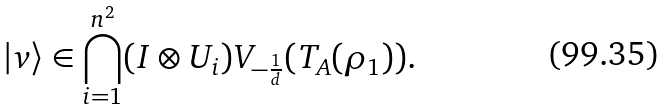Convert formula to latex. <formula><loc_0><loc_0><loc_500><loc_500>| v \rangle \in \bigcap _ { i = 1 } ^ { n ^ { 2 } } ( I \otimes U _ { i } ) V _ { - \frac { 1 } { d } } ( T _ { A } ( \rho _ { 1 } ) ) .</formula> 